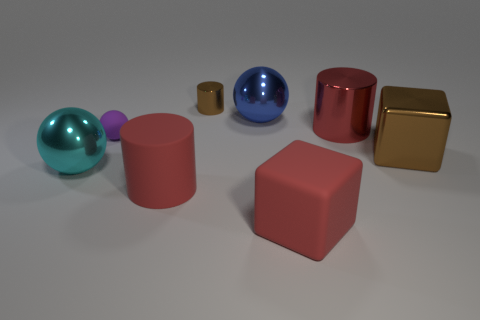The matte object that is behind the large ball that is left of the brown cylinder is what shape?
Your answer should be compact. Sphere. There is a big cylinder that is in front of the metal ball that is on the left side of the tiny rubber object; is there a big red thing that is behind it?
Keep it short and to the point. Yes. The other rubber block that is the same size as the brown block is what color?
Offer a terse response. Red. What is the shape of the object that is both in front of the cyan shiny sphere and behind the large red cube?
Provide a succinct answer. Cylinder. There is a brown thing that is to the left of the block that is right of the matte cube; how big is it?
Your response must be concise. Small. How many metallic balls are the same color as the small matte ball?
Your response must be concise. 0. How many other things are the same size as the blue sphere?
Ensure brevity in your answer.  5. What is the size of the object that is behind the large brown shiny cube and left of the rubber cylinder?
Keep it short and to the point. Small. How many other tiny things have the same shape as the blue metal object?
Keep it short and to the point. 1. What material is the big cyan sphere?
Provide a short and direct response. Metal. 